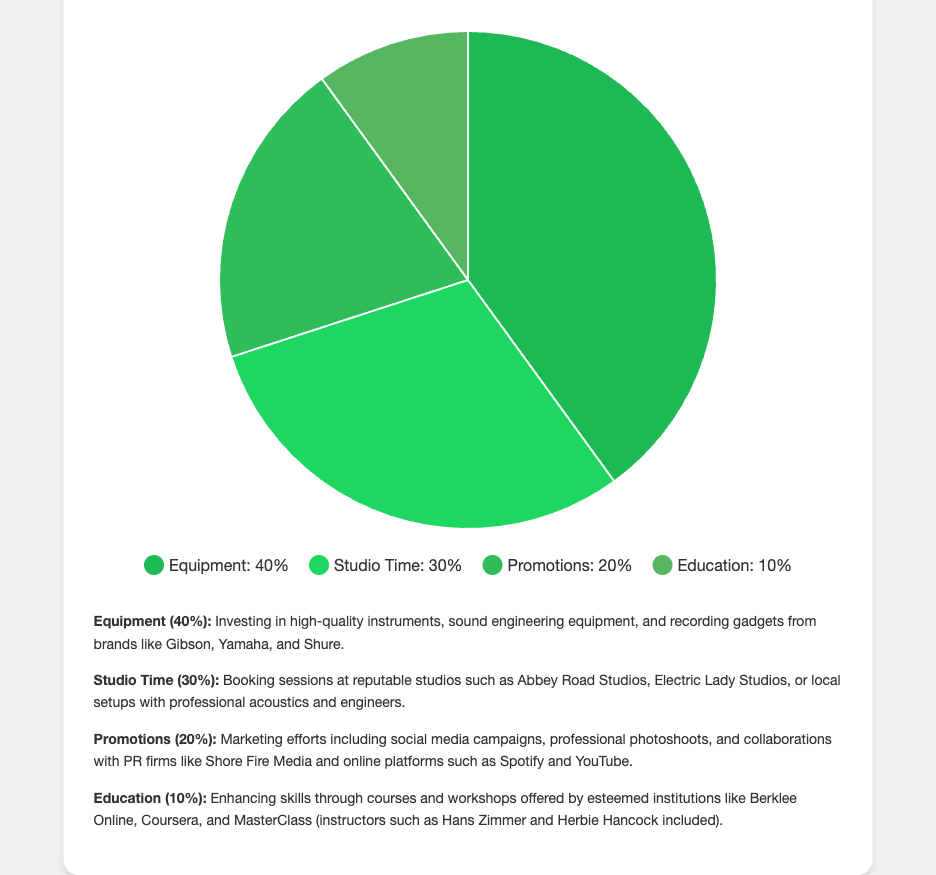What is the largest allocation category for the annual budget? The pie chart shows that "Equipment" has the highest percentage allocated at 40%.
Answer: Equipment Which category has the smallest budget allocation? From the visual inspection of the pie chart, "Education" has the smallest slice, indicating it has the smallest allocation at 10%.
Answer: Education How much more percentage is allocated to Equipment than to Promotions? The Equipment slice represents 40%, and Promotions represent 20%. Subtracting the two percentages gives 40% - 20% = 20%.
Answer: 20% What percentage of the budget is allocated to non-equipment expenses? Adding the percentages of Studio Time, Promotions, and Education gives 30% + 20% + 10% = 60%.
Answer: 60% If you combine the allocations for Studio Time and Promotions, how does this compare to the Equipment allocation? Adding Studio Time and Promotions (30% + 20%) gives 50%. Since 50% is more than the 40% allocated to Equipment, Studio Time and Promotions combined have a higher allocation.
Answer: More What percentage of the budget is allocated to skill enhancement (Education)? The pie chart indicates 10% of the budget is dedicated to "Education" for enhancing skills.
Answer: 10% By what factor does the budget allocation for Equipment exceed that for Education? The budget for Equipment is 40%, and for Education, it's 10%. Dividing these percentages gives 40% / 10% = 4.
Answer: 4 Which category’s expense is color-coded in the brightest green shade? The brightest green color (a shade such as #1db954) corresponds to the "Equipment" category.
Answer: Equipment Compare the budget allocations for Promotions and Studio Time in terms of greater than or less than. The pie chart shows that Promotions have a 20% allocation, while Studio Time has 30%. Therefore, Promotions < Studio Time.
Answer: Promotions < Studio Time 